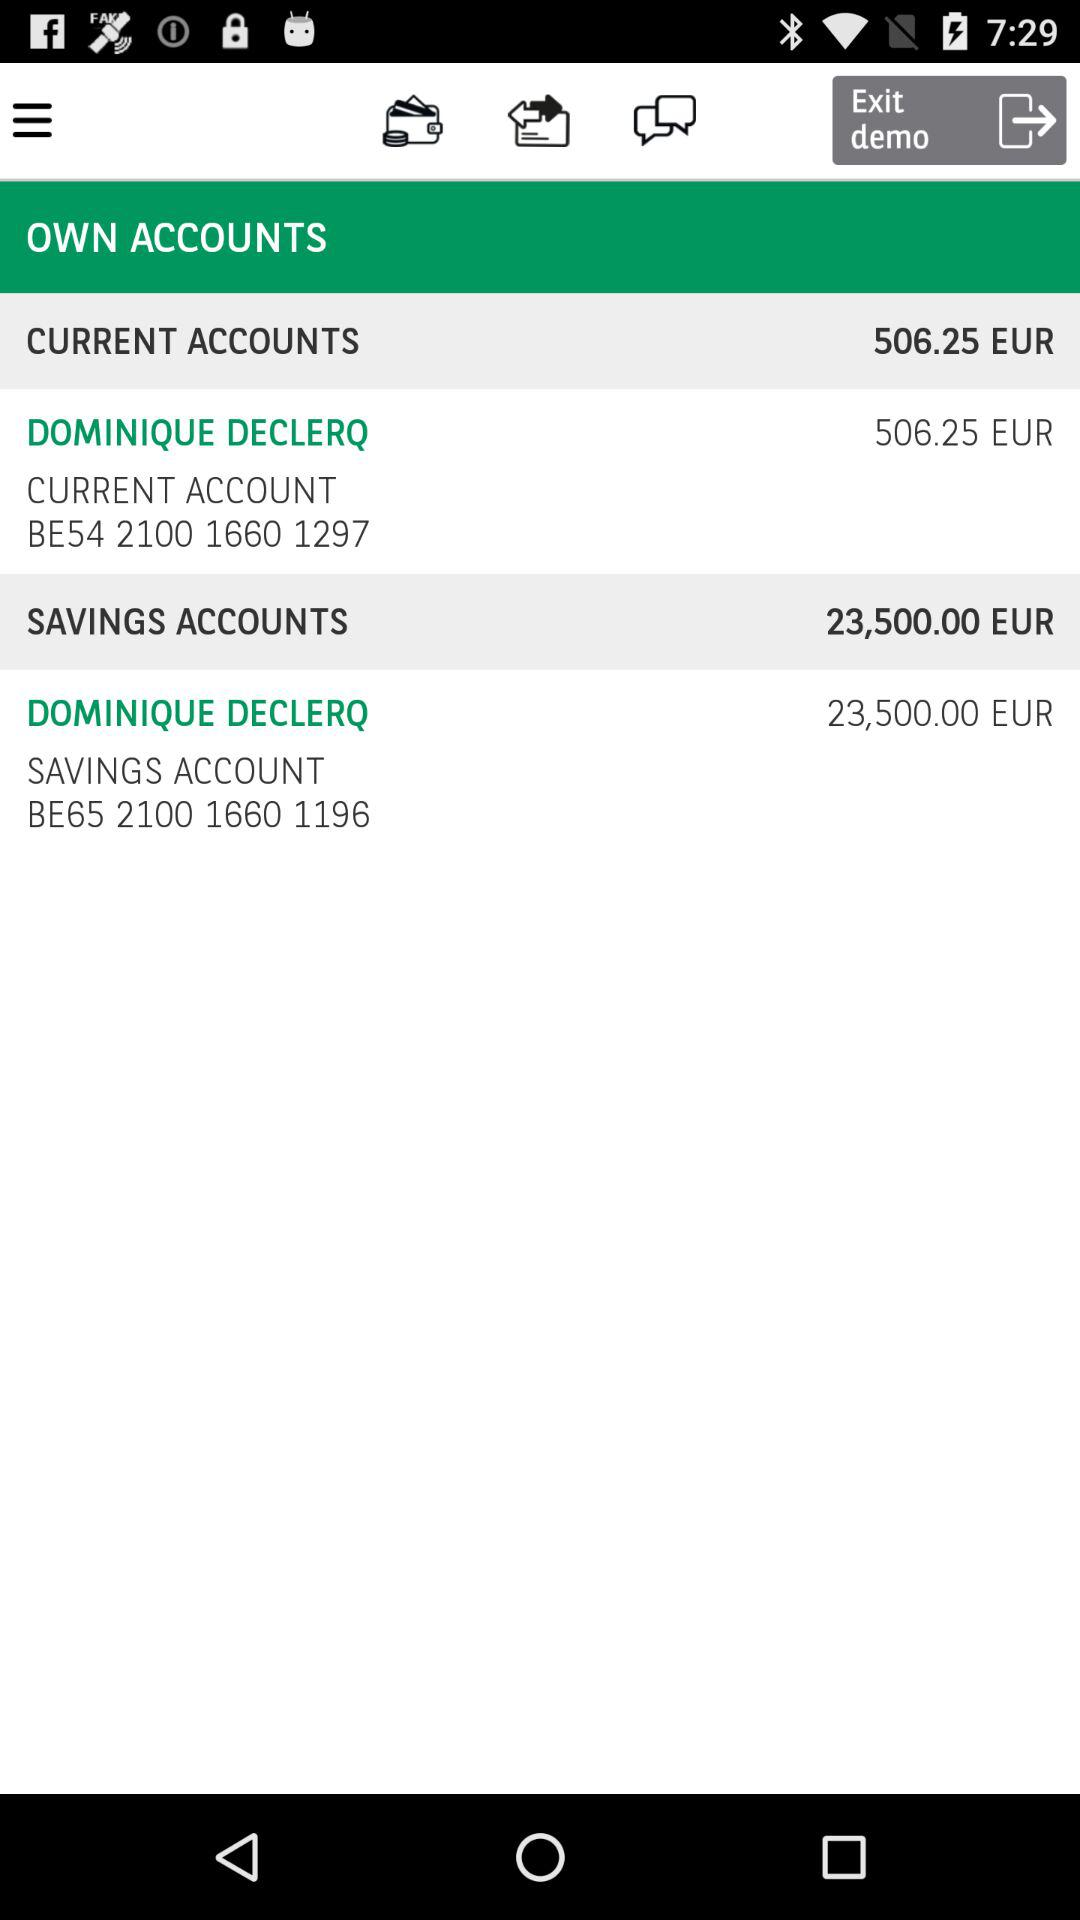What is the balance in the savings account? The balance in the savings account is 23,500 euros. 